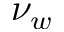<formula> <loc_0><loc_0><loc_500><loc_500>\nu _ { w }</formula> 